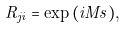<formula> <loc_0><loc_0><loc_500><loc_500>R _ { j i } = \exp { ( i M s ) } ,</formula> 